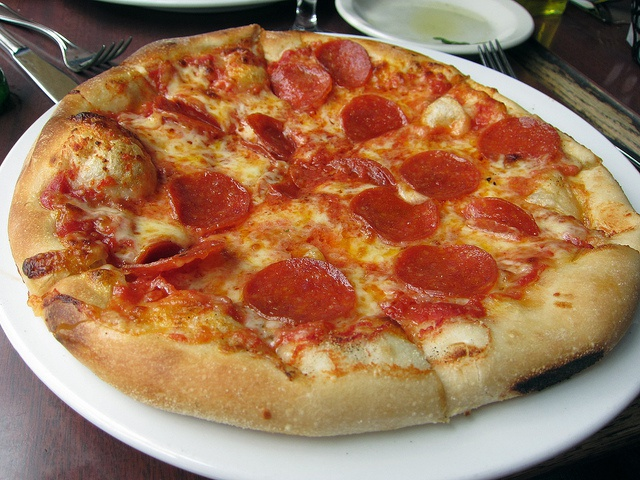Describe the objects in this image and their specific colors. I can see pizza in maroon, brown, and tan tones, dining table in maroon, black, and gray tones, dining table in maroon, black, gray, and brown tones, fork in maroon, gray, black, white, and darkgray tones, and knife in maroon, gray, white, and black tones in this image. 